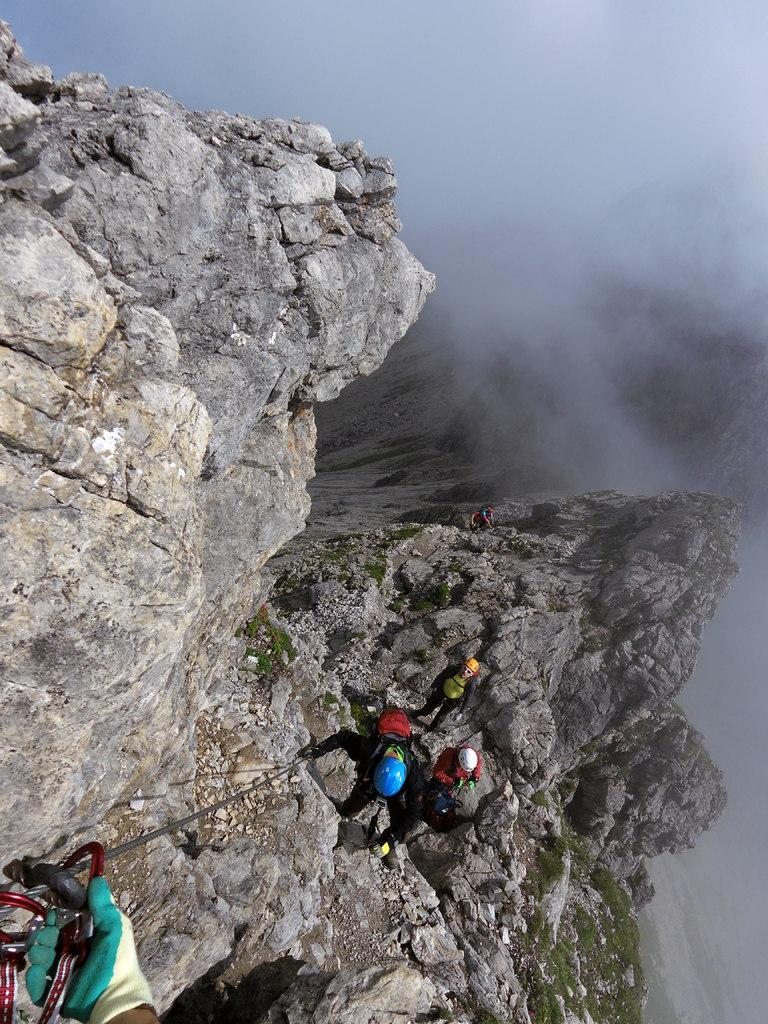How many people are in the image? There are people in the image, but the exact number is not specified. However, we know that one person is climbing a rock mountain, and three other persons are standing. So, there are at least four people in the image. What are the people doing in the image? One person is climbing a rock mountain, and three other persons are standing. What safety equipment are the people wearing in the image? All the people are wearing helmets on their heads. What type of bead is hanging from the rock mountain in the image? There is no bead hanging from the rock mountain in the image. What color is the beam that the people are standing on in the image? There is no beam present in the image; the people are standing on the ground. 